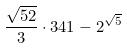Convert formula to latex. <formula><loc_0><loc_0><loc_500><loc_500>\frac { \sqrt { 5 2 } } { 3 } \cdot 3 4 1 - 2 ^ { \sqrt { 5 } }</formula> 